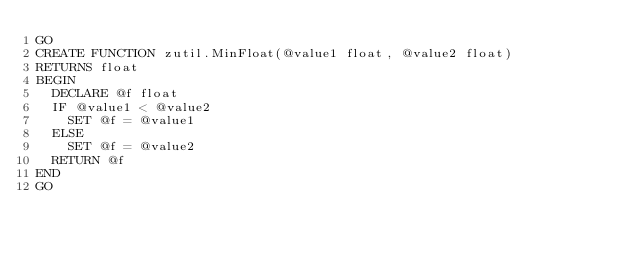<code> <loc_0><loc_0><loc_500><loc_500><_SQL_>GO
CREATE FUNCTION zutil.MinFloat(@value1 float, @value2 float)
RETURNS float
BEGIN
  DECLARE @f float
  IF @value1 < @value2
    SET @f = @value1
  ELSE
    SET @f = @value2
  RETURN @f
END
GO
</code> 